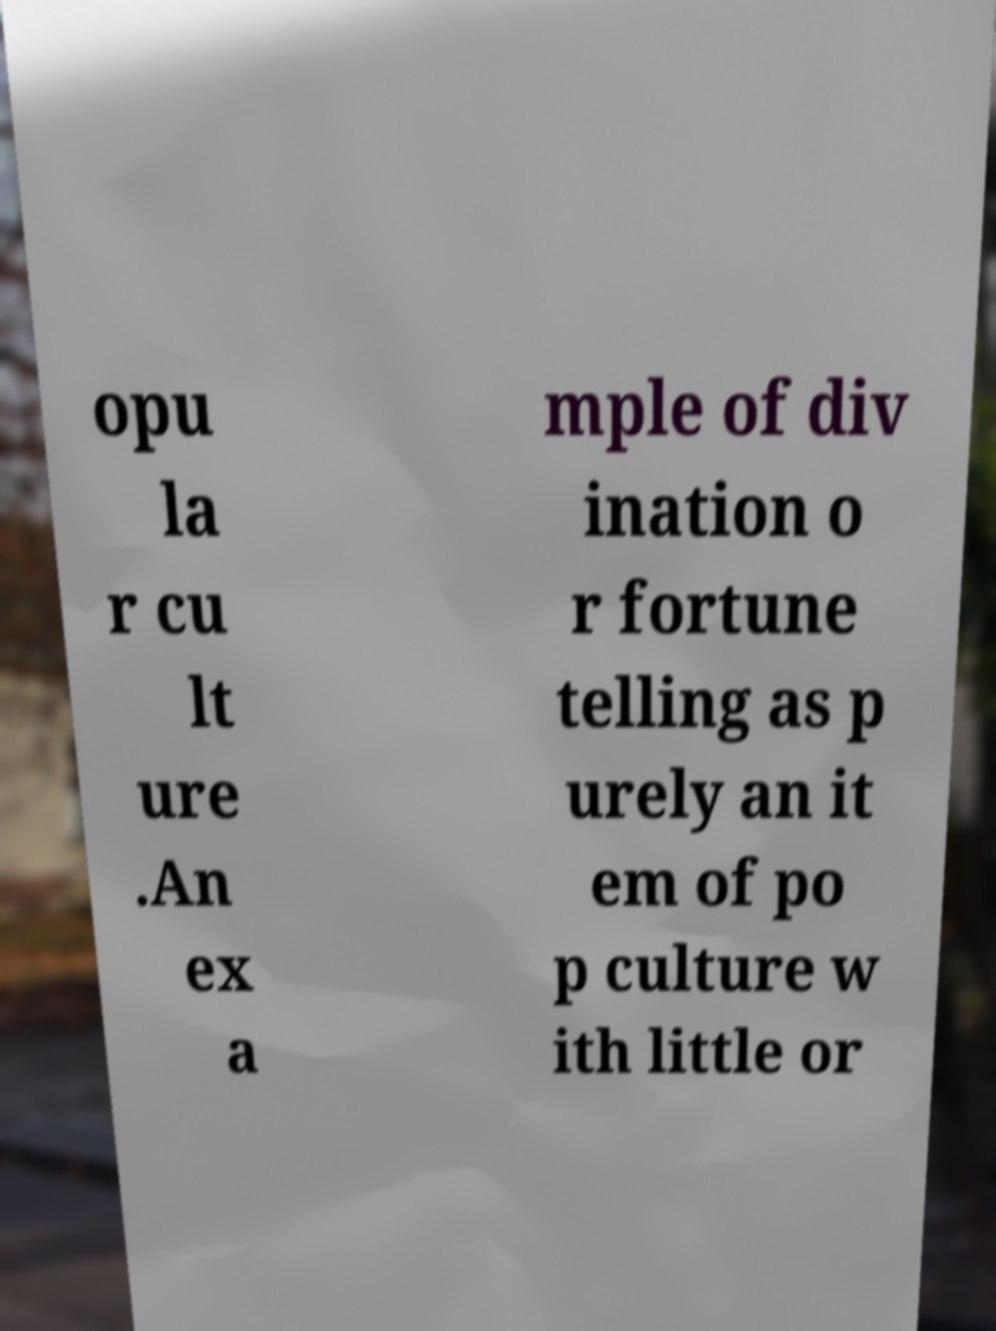I need the written content from this picture converted into text. Can you do that? opu la r cu lt ure .An ex a mple of div ination o r fortune telling as p urely an it em of po p culture w ith little or 